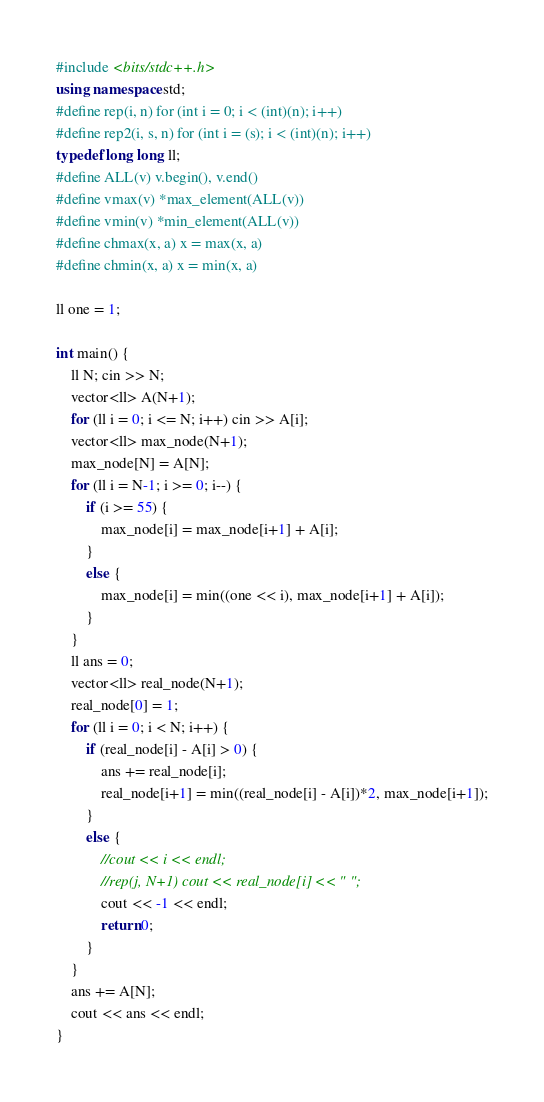Convert code to text. <code><loc_0><loc_0><loc_500><loc_500><_C++_>#include <bits/stdc++.h>
using namespace std;
#define rep(i, n) for (int i = 0; i < (int)(n); i++)
#define rep2(i, s, n) for (int i = (s); i < (int)(n); i++)
typedef long long ll;
#define ALL(v) v.begin(), v.end()
#define vmax(v) *max_element(ALL(v))
#define vmin(v) *min_element(ALL(v))
#define chmax(x, a) x = max(x, a)
#define chmin(x, a) x = min(x, a)

ll one = 1;

int main() {
    ll N; cin >> N;
    vector<ll> A(N+1);
    for (ll i = 0; i <= N; i++) cin >> A[i];
    vector<ll> max_node(N+1);
    max_node[N] = A[N];
    for (ll i = N-1; i >= 0; i--) {
        if (i >= 55) {
            max_node[i] = max_node[i+1] + A[i];
        }
        else {
            max_node[i] = min((one << i), max_node[i+1] + A[i]);
        }
    }
    ll ans = 0;
    vector<ll> real_node(N+1);
    real_node[0] = 1;
    for (ll i = 0; i < N; i++) {
        if (real_node[i] - A[i] > 0) {
            ans += real_node[i];
            real_node[i+1] = min((real_node[i] - A[i])*2, max_node[i+1]);
        }
        else {
            //cout << i << endl;
            //rep(j, N+1) cout << real_node[i] << " ";
            cout << -1 << endl;
            return 0;
        }
    }
    ans += A[N];
    cout << ans << endl;
}
</code> 